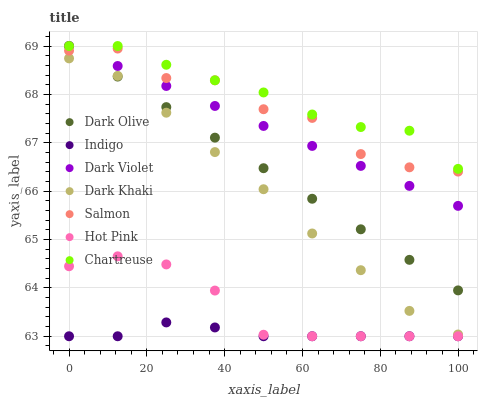Does Indigo have the minimum area under the curve?
Answer yes or no. Yes. Does Chartreuse have the maximum area under the curve?
Answer yes or no. Yes. Does Dark Olive have the minimum area under the curve?
Answer yes or no. No. Does Dark Olive have the maximum area under the curve?
Answer yes or no. No. Is Dark Olive the smoothest?
Answer yes or no. Yes. Is Salmon the roughest?
Answer yes or no. Yes. Is Indigo the smoothest?
Answer yes or no. No. Is Indigo the roughest?
Answer yes or no. No. Does Hot Pink have the lowest value?
Answer yes or no. Yes. Does Dark Olive have the lowest value?
Answer yes or no. No. Does Chartreuse have the highest value?
Answer yes or no. Yes. Does Indigo have the highest value?
Answer yes or no. No. Is Indigo less than Dark Violet?
Answer yes or no. Yes. Is Dark Olive greater than Hot Pink?
Answer yes or no. Yes. Does Salmon intersect Chartreuse?
Answer yes or no. Yes. Is Salmon less than Chartreuse?
Answer yes or no. No. Is Salmon greater than Chartreuse?
Answer yes or no. No. Does Indigo intersect Dark Violet?
Answer yes or no. No. 